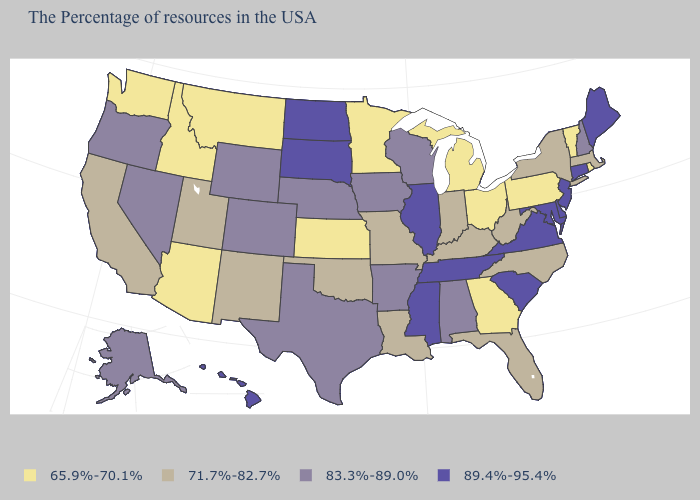What is the lowest value in the South?
Be succinct. 65.9%-70.1%. What is the value of South Carolina?
Keep it brief. 89.4%-95.4%. What is the value of Connecticut?
Answer briefly. 89.4%-95.4%. What is the value of Rhode Island?
Quick response, please. 65.9%-70.1%. Name the states that have a value in the range 71.7%-82.7%?
Keep it brief. Massachusetts, New York, North Carolina, West Virginia, Florida, Kentucky, Indiana, Louisiana, Missouri, Oklahoma, New Mexico, Utah, California. Name the states that have a value in the range 71.7%-82.7%?
Give a very brief answer. Massachusetts, New York, North Carolina, West Virginia, Florida, Kentucky, Indiana, Louisiana, Missouri, Oklahoma, New Mexico, Utah, California. What is the value of Tennessee?
Concise answer only. 89.4%-95.4%. What is the value of Delaware?
Concise answer only. 89.4%-95.4%. How many symbols are there in the legend?
Be succinct. 4. Name the states that have a value in the range 89.4%-95.4%?
Keep it brief. Maine, Connecticut, New Jersey, Delaware, Maryland, Virginia, South Carolina, Tennessee, Illinois, Mississippi, South Dakota, North Dakota, Hawaii. What is the value of North Carolina?
Give a very brief answer. 71.7%-82.7%. Does North Carolina have a lower value than Missouri?
Concise answer only. No. What is the value of California?
Answer briefly. 71.7%-82.7%. 